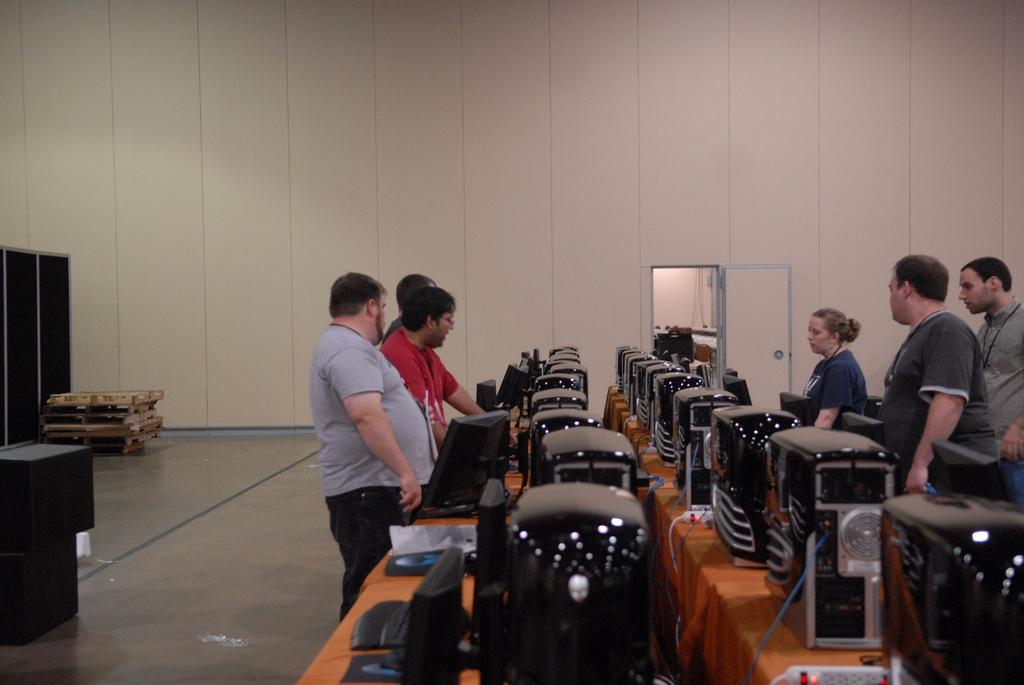Can you describe this image briefly? This picture is taken inside the room. In this image, on the right side, we can see three people are standing in front of the table, on the table, we can see some electronic machines, monitor, keyboard and a paper and some electrical wires. In the middle of the image, we can see three people are standing on the floor. On the left side, we can see some electronic instrument, table, shelf. In the background, we can see a door which is opened and a wall. 